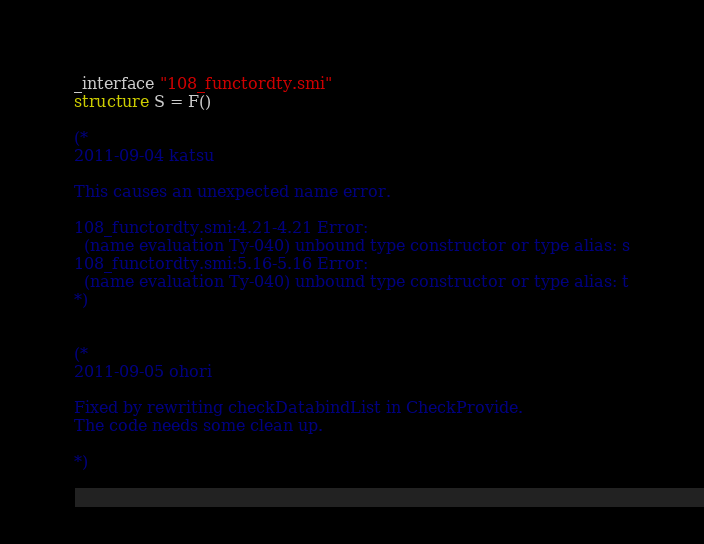Convert code to text. <code><loc_0><loc_0><loc_500><loc_500><_SML_>_interface "108_functordty.smi"
structure S = F()

(*
2011-09-04 katsu

This causes an unexpected name error.

108_functordty.smi:4.21-4.21 Error:
  (name evaluation Ty-040) unbound type constructor or type alias: s
108_functordty.smi:5.16-5.16 Error:
  (name evaluation Ty-040) unbound type constructor or type alias: t
*)


(*
2011-09-05 ohori

Fixed by rewriting checkDatabindList in CheckProvide.
The code needs some clean up.

*)
</code> 